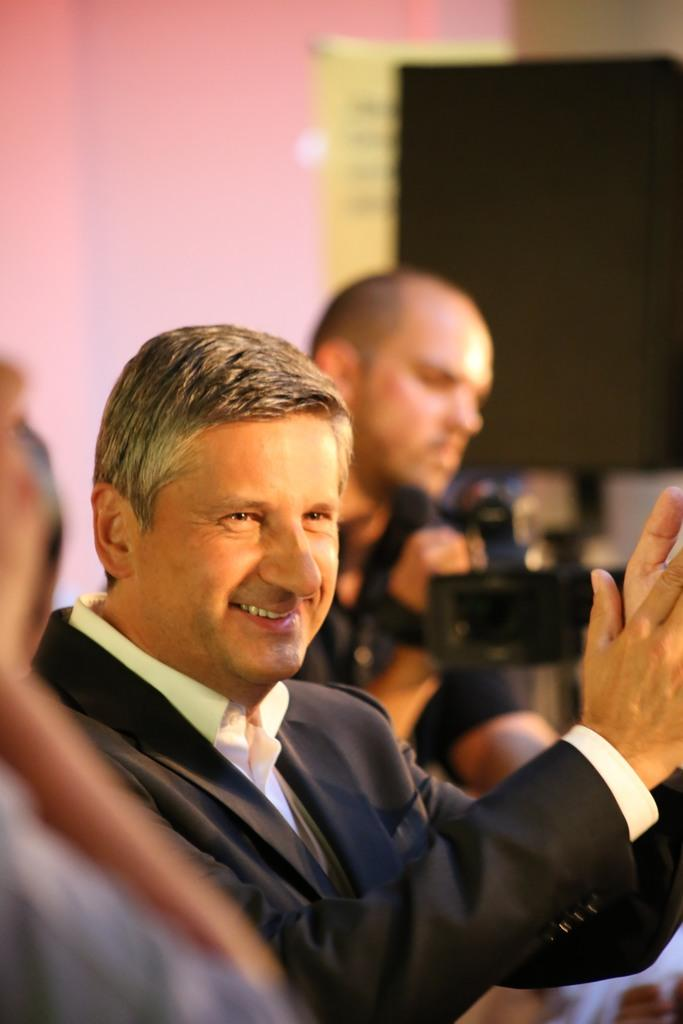How many people are in the image? There are people in the image. What is one person doing in the image? One person is smiling and clapping their hands. What is another person holding in the image? Another person is holding a camera. What can be seen in the background of the image? The background is blurred, and there is a wall and a blackboard in the background. What are the hobbies of the people in the image? The provided facts do not mention the hobbies of the people in the image, so we cannot determine their hobbies from the image. What type of dress is the person wearing in the image? The provided facts do not mention the clothing of the people in the image, so we cannot determine the type of dress they are wearing. 